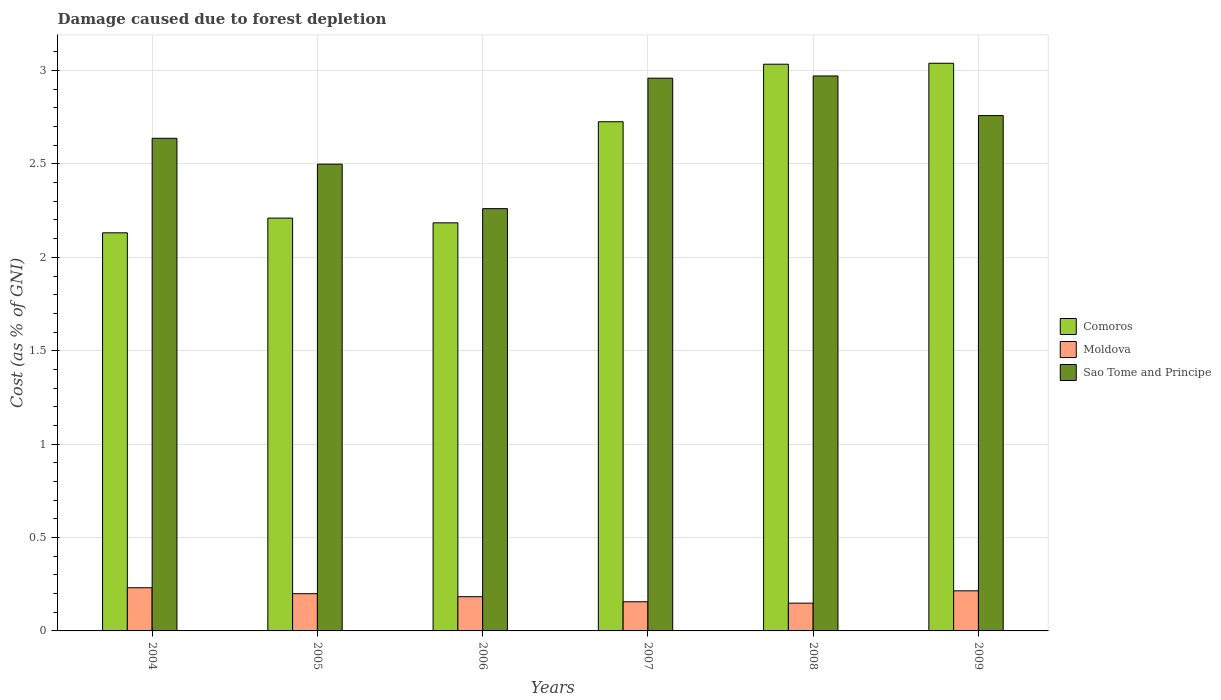How many groups of bars are there?
Make the answer very short. 6. How many bars are there on the 5th tick from the right?
Provide a short and direct response. 3. What is the label of the 4th group of bars from the left?
Your answer should be compact. 2007. In how many cases, is the number of bars for a given year not equal to the number of legend labels?
Give a very brief answer. 0. What is the cost of damage caused due to forest depletion in Sao Tome and Principe in 2009?
Offer a very short reply. 2.76. Across all years, what is the maximum cost of damage caused due to forest depletion in Moldova?
Offer a terse response. 0.23. Across all years, what is the minimum cost of damage caused due to forest depletion in Comoros?
Keep it short and to the point. 2.13. In which year was the cost of damage caused due to forest depletion in Comoros minimum?
Offer a very short reply. 2004. What is the total cost of damage caused due to forest depletion in Sao Tome and Principe in the graph?
Provide a succinct answer. 16.09. What is the difference between the cost of damage caused due to forest depletion in Sao Tome and Principe in 2006 and that in 2008?
Give a very brief answer. -0.71. What is the difference between the cost of damage caused due to forest depletion in Moldova in 2008 and the cost of damage caused due to forest depletion in Sao Tome and Principe in 2007?
Provide a short and direct response. -2.81. What is the average cost of damage caused due to forest depletion in Comoros per year?
Ensure brevity in your answer.  2.55. In the year 2005, what is the difference between the cost of damage caused due to forest depletion in Comoros and cost of damage caused due to forest depletion in Sao Tome and Principe?
Make the answer very short. -0.29. In how many years, is the cost of damage caused due to forest depletion in Comoros greater than 2.8 %?
Your answer should be compact. 2. What is the ratio of the cost of damage caused due to forest depletion in Comoros in 2005 to that in 2009?
Keep it short and to the point. 0.73. Is the difference between the cost of damage caused due to forest depletion in Comoros in 2004 and 2007 greater than the difference between the cost of damage caused due to forest depletion in Sao Tome and Principe in 2004 and 2007?
Give a very brief answer. No. What is the difference between the highest and the second highest cost of damage caused due to forest depletion in Sao Tome and Principe?
Give a very brief answer. 0.01. What is the difference between the highest and the lowest cost of damage caused due to forest depletion in Moldova?
Your response must be concise. 0.08. Is the sum of the cost of damage caused due to forest depletion in Comoros in 2004 and 2009 greater than the maximum cost of damage caused due to forest depletion in Moldova across all years?
Your answer should be very brief. Yes. What does the 2nd bar from the left in 2009 represents?
Give a very brief answer. Moldova. What does the 3rd bar from the right in 2009 represents?
Your answer should be very brief. Comoros. Is it the case that in every year, the sum of the cost of damage caused due to forest depletion in Moldova and cost of damage caused due to forest depletion in Comoros is greater than the cost of damage caused due to forest depletion in Sao Tome and Principe?
Offer a very short reply. No. How many bars are there?
Provide a short and direct response. 18. How many years are there in the graph?
Make the answer very short. 6. What is the difference between two consecutive major ticks on the Y-axis?
Keep it short and to the point. 0.5. Does the graph contain any zero values?
Your answer should be compact. No. Does the graph contain grids?
Make the answer very short. Yes. How many legend labels are there?
Your answer should be compact. 3. How are the legend labels stacked?
Ensure brevity in your answer.  Vertical. What is the title of the graph?
Provide a short and direct response. Damage caused due to forest depletion. Does "Zimbabwe" appear as one of the legend labels in the graph?
Give a very brief answer. No. What is the label or title of the X-axis?
Keep it short and to the point. Years. What is the label or title of the Y-axis?
Your answer should be compact. Cost (as % of GNI). What is the Cost (as % of GNI) of Comoros in 2004?
Make the answer very short. 2.13. What is the Cost (as % of GNI) in Moldova in 2004?
Ensure brevity in your answer.  0.23. What is the Cost (as % of GNI) in Sao Tome and Principe in 2004?
Your response must be concise. 2.64. What is the Cost (as % of GNI) in Comoros in 2005?
Offer a terse response. 2.21. What is the Cost (as % of GNI) in Moldova in 2005?
Your answer should be very brief. 0.2. What is the Cost (as % of GNI) of Sao Tome and Principe in 2005?
Provide a succinct answer. 2.5. What is the Cost (as % of GNI) of Comoros in 2006?
Provide a succinct answer. 2.18. What is the Cost (as % of GNI) of Moldova in 2006?
Provide a short and direct response. 0.18. What is the Cost (as % of GNI) of Sao Tome and Principe in 2006?
Your answer should be very brief. 2.26. What is the Cost (as % of GNI) of Comoros in 2007?
Provide a short and direct response. 2.73. What is the Cost (as % of GNI) in Moldova in 2007?
Your answer should be very brief. 0.16. What is the Cost (as % of GNI) in Sao Tome and Principe in 2007?
Provide a short and direct response. 2.96. What is the Cost (as % of GNI) in Comoros in 2008?
Make the answer very short. 3.03. What is the Cost (as % of GNI) in Moldova in 2008?
Give a very brief answer. 0.15. What is the Cost (as % of GNI) in Sao Tome and Principe in 2008?
Offer a very short reply. 2.97. What is the Cost (as % of GNI) in Comoros in 2009?
Ensure brevity in your answer.  3.04. What is the Cost (as % of GNI) of Moldova in 2009?
Offer a very short reply. 0.21. What is the Cost (as % of GNI) of Sao Tome and Principe in 2009?
Ensure brevity in your answer.  2.76. Across all years, what is the maximum Cost (as % of GNI) of Comoros?
Offer a terse response. 3.04. Across all years, what is the maximum Cost (as % of GNI) in Moldova?
Make the answer very short. 0.23. Across all years, what is the maximum Cost (as % of GNI) of Sao Tome and Principe?
Provide a succinct answer. 2.97. Across all years, what is the minimum Cost (as % of GNI) of Comoros?
Give a very brief answer. 2.13. Across all years, what is the minimum Cost (as % of GNI) in Moldova?
Your response must be concise. 0.15. Across all years, what is the minimum Cost (as % of GNI) of Sao Tome and Principe?
Your answer should be compact. 2.26. What is the total Cost (as % of GNI) of Comoros in the graph?
Give a very brief answer. 15.33. What is the total Cost (as % of GNI) of Moldova in the graph?
Provide a succinct answer. 1.13. What is the total Cost (as % of GNI) in Sao Tome and Principe in the graph?
Your answer should be very brief. 16.09. What is the difference between the Cost (as % of GNI) in Comoros in 2004 and that in 2005?
Give a very brief answer. -0.08. What is the difference between the Cost (as % of GNI) of Moldova in 2004 and that in 2005?
Your answer should be very brief. 0.03. What is the difference between the Cost (as % of GNI) in Sao Tome and Principe in 2004 and that in 2005?
Your answer should be very brief. 0.14. What is the difference between the Cost (as % of GNI) of Comoros in 2004 and that in 2006?
Your response must be concise. -0.05. What is the difference between the Cost (as % of GNI) of Moldova in 2004 and that in 2006?
Provide a short and direct response. 0.05. What is the difference between the Cost (as % of GNI) of Sao Tome and Principe in 2004 and that in 2006?
Provide a short and direct response. 0.38. What is the difference between the Cost (as % of GNI) of Comoros in 2004 and that in 2007?
Ensure brevity in your answer.  -0.59. What is the difference between the Cost (as % of GNI) in Moldova in 2004 and that in 2007?
Ensure brevity in your answer.  0.07. What is the difference between the Cost (as % of GNI) of Sao Tome and Principe in 2004 and that in 2007?
Provide a short and direct response. -0.32. What is the difference between the Cost (as % of GNI) of Comoros in 2004 and that in 2008?
Your answer should be very brief. -0.9. What is the difference between the Cost (as % of GNI) in Moldova in 2004 and that in 2008?
Provide a succinct answer. 0.08. What is the difference between the Cost (as % of GNI) in Sao Tome and Principe in 2004 and that in 2008?
Offer a very short reply. -0.33. What is the difference between the Cost (as % of GNI) of Comoros in 2004 and that in 2009?
Provide a succinct answer. -0.91. What is the difference between the Cost (as % of GNI) of Moldova in 2004 and that in 2009?
Give a very brief answer. 0.02. What is the difference between the Cost (as % of GNI) in Sao Tome and Principe in 2004 and that in 2009?
Ensure brevity in your answer.  -0.12. What is the difference between the Cost (as % of GNI) in Comoros in 2005 and that in 2006?
Make the answer very short. 0.03. What is the difference between the Cost (as % of GNI) of Moldova in 2005 and that in 2006?
Ensure brevity in your answer.  0.02. What is the difference between the Cost (as % of GNI) in Sao Tome and Principe in 2005 and that in 2006?
Your answer should be compact. 0.24. What is the difference between the Cost (as % of GNI) of Comoros in 2005 and that in 2007?
Ensure brevity in your answer.  -0.52. What is the difference between the Cost (as % of GNI) in Moldova in 2005 and that in 2007?
Offer a terse response. 0.04. What is the difference between the Cost (as % of GNI) in Sao Tome and Principe in 2005 and that in 2007?
Your answer should be very brief. -0.46. What is the difference between the Cost (as % of GNI) of Comoros in 2005 and that in 2008?
Your response must be concise. -0.82. What is the difference between the Cost (as % of GNI) of Moldova in 2005 and that in 2008?
Your answer should be compact. 0.05. What is the difference between the Cost (as % of GNI) of Sao Tome and Principe in 2005 and that in 2008?
Offer a very short reply. -0.47. What is the difference between the Cost (as % of GNI) of Comoros in 2005 and that in 2009?
Your response must be concise. -0.83. What is the difference between the Cost (as % of GNI) of Moldova in 2005 and that in 2009?
Your answer should be very brief. -0.02. What is the difference between the Cost (as % of GNI) in Sao Tome and Principe in 2005 and that in 2009?
Offer a very short reply. -0.26. What is the difference between the Cost (as % of GNI) in Comoros in 2006 and that in 2007?
Offer a very short reply. -0.54. What is the difference between the Cost (as % of GNI) in Moldova in 2006 and that in 2007?
Provide a succinct answer. 0.03. What is the difference between the Cost (as % of GNI) in Sao Tome and Principe in 2006 and that in 2007?
Your answer should be very brief. -0.7. What is the difference between the Cost (as % of GNI) of Comoros in 2006 and that in 2008?
Give a very brief answer. -0.85. What is the difference between the Cost (as % of GNI) in Moldova in 2006 and that in 2008?
Offer a terse response. 0.03. What is the difference between the Cost (as % of GNI) in Sao Tome and Principe in 2006 and that in 2008?
Give a very brief answer. -0.71. What is the difference between the Cost (as % of GNI) of Comoros in 2006 and that in 2009?
Your answer should be compact. -0.85. What is the difference between the Cost (as % of GNI) of Moldova in 2006 and that in 2009?
Offer a very short reply. -0.03. What is the difference between the Cost (as % of GNI) of Sao Tome and Principe in 2006 and that in 2009?
Provide a short and direct response. -0.5. What is the difference between the Cost (as % of GNI) of Comoros in 2007 and that in 2008?
Provide a succinct answer. -0.31. What is the difference between the Cost (as % of GNI) in Moldova in 2007 and that in 2008?
Provide a short and direct response. 0.01. What is the difference between the Cost (as % of GNI) in Sao Tome and Principe in 2007 and that in 2008?
Your answer should be very brief. -0.01. What is the difference between the Cost (as % of GNI) in Comoros in 2007 and that in 2009?
Offer a very short reply. -0.31. What is the difference between the Cost (as % of GNI) of Moldova in 2007 and that in 2009?
Make the answer very short. -0.06. What is the difference between the Cost (as % of GNI) of Sao Tome and Principe in 2007 and that in 2009?
Offer a terse response. 0.2. What is the difference between the Cost (as % of GNI) of Comoros in 2008 and that in 2009?
Keep it short and to the point. -0.01. What is the difference between the Cost (as % of GNI) of Moldova in 2008 and that in 2009?
Ensure brevity in your answer.  -0.07. What is the difference between the Cost (as % of GNI) of Sao Tome and Principe in 2008 and that in 2009?
Offer a very short reply. 0.21. What is the difference between the Cost (as % of GNI) of Comoros in 2004 and the Cost (as % of GNI) of Moldova in 2005?
Provide a succinct answer. 1.93. What is the difference between the Cost (as % of GNI) of Comoros in 2004 and the Cost (as % of GNI) of Sao Tome and Principe in 2005?
Keep it short and to the point. -0.37. What is the difference between the Cost (as % of GNI) in Moldova in 2004 and the Cost (as % of GNI) in Sao Tome and Principe in 2005?
Make the answer very short. -2.27. What is the difference between the Cost (as % of GNI) in Comoros in 2004 and the Cost (as % of GNI) in Moldova in 2006?
Your answer should be very brief. 1.95. What is the difference between the Cost (as % of GNI) in Comoros in 2004 and the Cost (as % of GNI) in Sao Tome and Principe in 2006?
Your response must be concise. -0.13. What is the difference between the Cost (as % of GNI) of Moldova in 2004 and the Cost (as % of GNI) of Sao Tome and Principe in 2006?
Give a very brief answer. -2.03. What is the difference between the Cost (as % of GNI) in Comoros in 2004 and the Cost (as % of GNI) in Moldova in 2007?
Keep it short and to the point. 1.98. What is the difference between the Cost (as % of GNI) of Comoros in 2004 and the Cost (as % of GNI) of Sao Tome and Principe in 2007?
Your response must be concise. -0.83. What is the difference between the Cost (as % of GNI) in Moldova in 2004 and the Cost (as % of GNI) in Sao Tome and Principe in 2007?
Your answer should be compact. -2.73. What is the difference between the Cost (as % of GNI) in Comoros in 2004 and the Cost (as % of GNI) in Moldova in 2008?
Give a very brief answer. 1.98. What is the difference between the Cost (as % of GNI) in Comoros in 2004 and the Cost (as % of GNI) in Sao Tome and Principe in 2008?
Provide a short and direct response. -0.84. What is the difference between the Cost (as % of GNI) of Moldova in 2004 and the Cost (as % of GNI) of Sao Tome and Principe in 2008?
Ensure brevity in your answer.  -2.74. What is the difference between the Cost (as % of GNI) in Comoros in 2004 and the Cost (as % of GNI) in Moldova in 2009?
Your answer should be compact. 1.92. What is the difference between the Cost (as % of GNI) of Comoros in 2004 and the Cost (as % of GNI) of Sao Tome and Principe in 2009?
Keep it short and to the point. -0.63. What is the difference between the Cost (as % of GNI) in Moldova in 2004 and the Cost (as % of GNI) in Sao Tome and Principe in 2009?
Your answer should be compact. -2.53. What is the difference between the Cost (as % of GNI) in Comoros in 2005 and the Cost (as % of GNI) in Moldova in 2006?
Your response must be concise. 2.03. What is the difference between the Cost (as % of GNI) in Comoros in 2005 and the Cost (as % of GNI) in Sao Tome and Principe in 2006?
Give a very brief answer. -0.05. What is the difference between the Cost (as % of GNI) in Moldova in 2005 and the Cost (as % of GNI) in Sao Tome and Principe in 2006?
Give a very brief answer. -2.06. What is the difference between the Cost (as % of GNI) of Comoros in 2005 and the Cost (as % of GNI) of Moldova in 2007?
Provide a succinct answer. 2.05. What is the difference between the Cost (as % of GNI) in Comoros in 2005 and the Cost (as % of GNI) in Sao Tome and Principe in 2007?
Ensure brevity in your answer.  -0.75. What is the difference between the Cost (as % of GNI) in Moldova in 2005 and the Cost (as % of GNI) in Sao Tome and Principe in 2007?
Your answer should be compact. -2.76. What is the difference between the Cost (as % of GNI) in Comoros in 2005 and the Cost (as % of GNI) in Moldova in 2008?
Give a very brief answer. 2.06. What is the difference between the Cost (as % of GNI) of Comoros in 2005 and the Cost (as % of GNI) of Sao Tome and Principe in 2008?
Your response must be concise. -0.76. What is the difference between the Cost (as % of GNI) in Moldova in 2005 and the Cost (as % of GNI) in Sao Tome and Principe in 2008?
Ensure brevity in your answer.  -2.77. What is the difference between the Cost (as % of GNI) of Comoros in 2005 and the Cost (as % of GNI) of Moldova in 2009?
Provide a succinct answer. 2. What is the difference between the Cost (as % of GNI) in Comoros in 2005 and the Cost (as % of GNI) in Sao Tome and Principe in 2009?
Offer a very short reply. -0.55. What is the difference between the Cost (as % of GNI) in Moldova in 2005 and the Cost (as % of GNI) in Sao Tome and Principe in 2009?
Offer a very short reply. -2.56. What is the difference between the Cost (as % of GNI) of Comoros in 2006 and the Cost (as % of GNI) of Moldova in 2007?
Provide a short and direct response. 2.03. What is the difference between the Cost (as % of GNI) in Comoros in 2006 and the Cost (as % of GNI) in Sao Tome and Principe in 2007?
Keep it short and to the point. -0.77. What is the difference between the Cost (as % of GNI) of Moldova in 2006 and the Cost (as % of GNI) of Sao Tome and Principe in 2007?
Your answer should be compact. -2.78. What is the difference between the Cost (as % of GNI) of Comoros in 2006 and the Cost (as % of GNI) of Moldova in 2008?
Provide a short and direct response. 2.04. What is the difference between the Cost (as % of GNI) of Comoros in 2006 and the Cost (as % of GNI) of Sao Tome and Principe in 2008?
Your answer should be compact. -0.79. What is the difference between the Cost (as % of GNI) of Moldova in 2006 and the Cost (as % of GNI) of Sao Tome and Principe in 2008?
Keep it short and to the point. -2.79. What is the difference between the Cost (as % of GNI) of Comoros in 2006 and the Cost (as % of GNI) of Moldova in 2009?
Your response must be concise. 1.97. What is the difference between the Cost (as % of GNI) in Comoros in 2006 and the Cost (as % of GNI) in Sao Tome and Principe in 2009?
Your response must be concise. -0.57. What is the difference between the Cost (as % of GNI) in Moldova in 2006 and the Cost (as % of GNI) in Sao Tome and Principe in 2009?
Your answer should be very brief. -2.58. What is the difference between the Cost (as % of GNI) in Comoros in 2007 and the Cost (as % of GNI) in Moldova in 2008?
Make the answer very short. 2.58. What is the difference between the Cost (as % of GNI) of Comoros in 2007 and the Cost (as % of GNI) of Sao Tome and Principe in 2008?
Offer a terse response. -0.25. What is the difference between the Cost (as % of GNI) in Moldova in 2007 and the Cost (as % of GNI) in Sao Tome and Principe in 2008?
Your answer should be compact. -2.81. What is the difference between the Cost (as % of GNI) of Comoros in 2007 and the Cost (as % of GNI) of Moldova in 2009?
Ensure brevity in your answer.  2.51. What is the difference between the Cost (as % of GNI) of Comoros in 2007 and the Cost (as % of GNI) of Sao Tome and Principe in 2009?
Your answer should be compact. -0.03. What is the difference between the Cost (as % of GNI) of Moldova in 2007 and the Cost (as % of GNI) of Sao Tome and Principe in 2009?
Offer a terse response. -2.6. What is the difference between the Cost (as % of GNI) of Comoros in 2008 and the Cost (as % of GNI) of Moldova in 2009?
Provide a short and direct response. 2.82. What is the difference between the Cost (as % of GNI) in Comoros in 2008 and the Cost (as % of GNI) in Sao Tome and Principe in 2009?
Keep it short and to the point. 0.28. What is the difference between the Cost (as % of GNI) of Moldova in 2008 and the Cost (as % of GNI) of Sao Tome and Principe in 2009?
Offer a terse response. -2.61. What is the average Cost (as % of GNI) in Comoros per year?
Your answer should be compact. 2.55. What is the average Cost (as % of GNI) in Moldova per year?
Ensure brevity in your answer.  0.19. What is the average Cost (as % of GNI) of Sao Tome and Principe per year?
Provide a short and direct response. 2.68. In the year 2004, what is the difference between the Cost (as % of GNI) in Comoros and Cost (as % of GNI) in Moldova?
Keep it short and to the point. 1.9. In the year 2004, what is the difference between the Cost (as % of GNI) of Comoros and Cost (as % of GNI) of Sao Tome and Principe?
Give a very brief answer. -0.51. In the year 2004, what is the difference between the Cost (as % of GNI) of Moldova and Cost (as % of GNI) of Sao Tome and Principe?
Provide a succinct answer. -2.41. In the year 2005, what is the difference between the Cost (as % of GNI) of Comoros and Cost (as % of GNI) of Moldova?
Offer a very short reply. 2.01. In the year 2005, what is the difference between the Cost (as % of GNI) in Comoros and Cost (as % of GNI) in Sao Tome and Principe?
Offer a terse response. -0.29. In the year 2005, what is the difference between the Cost (as % of GNI) of Moldova and Cost (as % of GNI) of Sao Tome and Principe?
Your response must be concise. -2.3. In the year 2006, what is the difference between the Cost (as % of GNI) of Comoros and Cost (as % of GNI) of Moldova?
Your answer should be compact. 2. In the year 2006, what is the difference between the Cost (as % of GNI) in Comoros and Cost (as % of GNI) in Sao Tome and Principe?
Give a very brief answer. -0.08. In the year 2006, what is the difference between the Cost (as % of GNI) in Moldova and Cost (as % of GNI) in Sao Tome and Principe?
Provide a short and direct response. -2.08. In the year 2007, what is the difference between the Cost (as % of GNI) in Comoros and Cost (as % of GNI) in Moldova?
Your answer should be compact. 2.57. In the year 2007, what is the difference between the Cost (as % of GNI) of Comoros and Cost (as % of GNI) of Sao Tome and Principe?
Ensure brevity in your answer.  -0.23. In the year 2007, what is the difference between the Cost (as % of GNI) in Moldova and Cost (as % of GNI) in Sao Tome and Principe?
Offer a very short reply. -2.8. In the year 2008, what is the difference between the Cost (as % of GNI) of Comoros and Cost (as % of GNI) of Moldova?
Your response must be concise. 2.89. In the year 2008, what is the difference between the Cost (as % of GNI) in Comoros and Cost (as % of GNI) in Sao Tome and Principe?
Provide a succinct answer. 0.06. In the year 2008, what is the difference between the Cost (as % of GNI) of Moldova and Cost (as % of GNI) of Sao Tome and Principe?
Your response must be concise. -2.82. In the year 2009, what is the difference between the Cost (as % of GNI) of Comoros and Cost (as % of GNI) of Moldova?
Keep it short and to the point. 2.82. In the year 2009, what is the difference between the Cost (as % of GNI) in Comoros and Cost (as % of GNI) in Sao Tome and Principe?
Your answer should be very brief. 0.28. In the year 2009, what is the difference between the Cost (as % of GNI) of Moldova and Cost (as % of GNI) of Sao Tome and Principe?
Provide a short and direct response. -2.54. What is the ratio of the Cost (as % of GNI) in Comoros in 2004 to that in 2005?
Your response must be concise. 0.96. What is the ratio of the Cost (as % of GNI) of Moldova in 2004 to that in 2005?
Offer a very short reply. 1.16. What is the ratio of the Cost (as % of GNI) of Sao Tome and Principe in 2004 to that in 2005?
Your answer should be very brief. 1.06. What is the ratio of the Cost (as % of GNI) of Comoros in 2004 to that in 2006?
Your answer should be compact. 0.98. What is the ratio of the Cost (as % of GNI) in Moldova in 2004 to that in 2006?
Your answer should be compact. 1.26. What is the ratio of the Cost (as % of GNI) in Sao Tome and Principe in 2004 to that in 2006?
Your answer should be compact. 1.17. What is the ratio of the Cost (as % of GNI) of Comoros in 2004 to that in 2007?
Make the answer very short. 0.78. What is the ratio of the Cost (as % of GNI) in Moldova in 2004 to that in 2007?
Your response must be concise. 1.48. What is the ratio of the Cost (as % of GNI) of Sao Tome and Principe in 2004 to that in 2007?
Your answer should be compact. 0.89. What is the ratio of the Cost (as % of GNI) of Comoros in 2004 to that in 2008?
Your answer should be very brief. 0.7. What is the ratio of the Cost (as % of GNI) of Moldova in 2004 to that in 2008?
Give a very brief answer. 1.55. What is the ratio of the Cost (as % of GNI) in Sao Tome and Principe in 2004 to that in 2008?
Ensure brevity in your answer.  0.89. What is the ratio of the Cost (as % of GNI) in Comoros in 2004 to that in 2009?
Your answer should be very brief. 0.7. What is the ratio of the Cost (as % of GNI) in Moldova in 2004 to that in 2009?
Provide a succinct answer. 1.08. What is the ratio of the Cost (as % of GNI) in Sao Tome and Principe in 2004 to that in 2009?
Your answer should be very brief. 0.96. What is the ratio of the Cost (as % of GNI) of Comoros in 2005 to that in 2006?
Keep it short and to the point. 1.01. What is the ratio of the Cost (as % of GNI) in Moldova in 2005 to that in 2006?
Offer a terse response. 1.09. What is the ratio of the Cost (as % of GNI) in Sao Tome and Principe in 2005 to that in 2006?
Ensure brevity in your answer.  1.11. What is the ratio of the Cost (as % of GNI) of Comoros in 2005 to that in 2007?
Your answer should be very brief. 0.81. What is the ratio of the Cost (as % of GNI) in Moldova in 2005 to that in 2007?
Your answer should be compact. 1.28. What is the ratio of the Cost (as % of GNI) in Sao Tome and Principe in 2005 to that in 2007?
Your response must be concise. 0.84. What is the ratio of the Cost (as % of GNI) in Comoros in 2005 to that in 2008?
Keep it short and to the point. 0.73. What is the ratio of the Cost (as % of GNI) in Moldova in 2005 to that in 2008?
Give a very brief answer. 1.34. What is the ratio of the Cost (as % of GNI) of Sao Tome and Principe in 2005 to that in 2008?
Your answer should be compact. 0.84. What is the ratio of the Cost (as % of GNI) in Comoros in 2005 to that in 2009?
Provide a short and direct response. 0.73. What is the ratio of the Cost (as % of GNI) in Moldova in 2005 to that in 2009?
Offer a terse response. 0.93. What is the ratio of the Cost (as % of GNI) in Sao Tome and Principe in 2005 to that in 2009?
Your response must be concise. 0.91. What is the ratio of the Cost (as % of GNI) in Comoros in 2006 to that in 2007?
Make the answer very short. 0.8. What is the ratio of the Cost (as % of GNI) in Moldova in 2006 to that in 2007?
Give a very brief answer. 1.17. What is the ratio of the Cost (as % of GNI) of Sao Tome and Principe in 2006 to that in 2007?
Ensure brevity in your answer.  0.76. What is the ratio of the Cost (as % of GNI) in Comoros in 2006 to that in 2008?
Provide a short and direct response. 0.72. What is the ratio of the Cost (as % of GNI) in Moldova in 2006 to that in 2008?
Make the answer very short. 1.23. What is the ratio of the Cost (as % of GNI) of Sao Tome and Principe in 2006 to that in 2008?
Your answer should be compact. 0.76. What is the ratio of the Cost (as % of GNI) in Comoros in 2006 to that in 2009?
Ensure brevity in your answer.  0.72. What is the ratio of the Cost (as % of GNI) in Moldova in 2006 to that in 2009?
Ensure brevity in your answer.  0.85. What is the ratio of the Cost (as % of GNI) of Sao Tome and Principe in 2006 to that in 2009?
Your answer should be compact. 0.82. What is the ratio of the Cost (as % of GNI) of Comoros in 2007 to that in 2008?
Your answer should be very brief. 0.9. What is the ratio of the Cost (as % of GNI) of Moldova in 2007 to that in 2008?
Your response must be concise. 1.05. What is the ratio of the Cost (as % of GNI) of Sao Tome and Principe in 2007 to that in 2008?
Your answer should be compact. 1. What is the ratio of the Cost (as % of GNI) of Comoros in 2007 to that in 2009?
Your answer should be compact. 0.9. What is the ratio of the Cost (as % of GNI) of Moldova in 2007 to that in 2009?
Give a very brief answer. 0.73. What is the ratio of the Cost (as % of GNI) of Sao Tome and Principe in 2007 to that in 2009?
Keep it short and to the point. 1.07. What is the ratio of the Cost (as % of GNI) in Comoros in 2008 to that in 2009?
Give a very brief answer. 1. What is the ratio of the Cost (as % of GNI) in Moldova in 2008 to that in 2009?
Make the answer very short. 0.69. What is the ratio of the Cost (as % of GNI) in Sao Tome and Principe in 2008 to that in 2009?
Your answer should be compact. 1.08. What is the difference between the highest and the second highest Cost (as % of GNI) of Comoros?
Keep it short and to the point. 0.01. What is the difference between the highest and the second highest Cost (as % of GNI) of Moldova?
Offer a terse response. 0.02. What is the difference between the highest and the second highest Cost (as % of GNI) of Sao Tome and Principe?
Your answer should be compact. 0.01. What is the difference between the highest and the lowest Cost (as % of GNI) in Comoros?
Give a very brief answer. 0.91. What is the difference between the highest and the lowest Cost (as % of GNI) of Moldova?
Offer a very short reply. 0.08. What is the difference between the highest and the lowest Cost (as % of GNI) in Sao Tome and Principe?
Give a very brief answer. 0.71. 